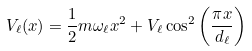Convert formula to latex. <formula><loc_0><loc_0><loc_500><loc_500>V _ { \ell } ( x ) = \frac { 1 } { 2 } m \omega _ { \ell } x ^ { 2 } + V _ { \ell } \cos ^ { 2 } \left ( \frac { \pi x } { d _ { \ell } } \right )</formula> 